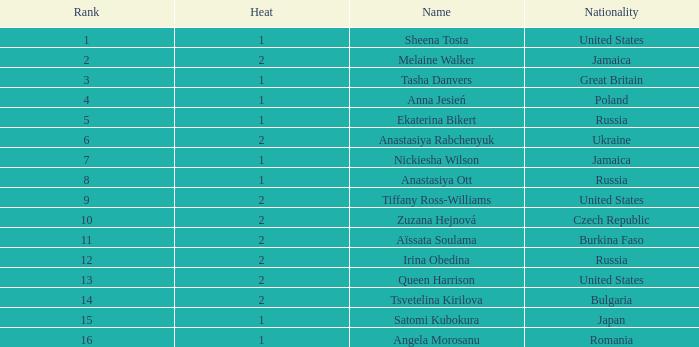Which Rank has a Name of tsvetelina kirilova, and a Result smaller than 55.97? None. 